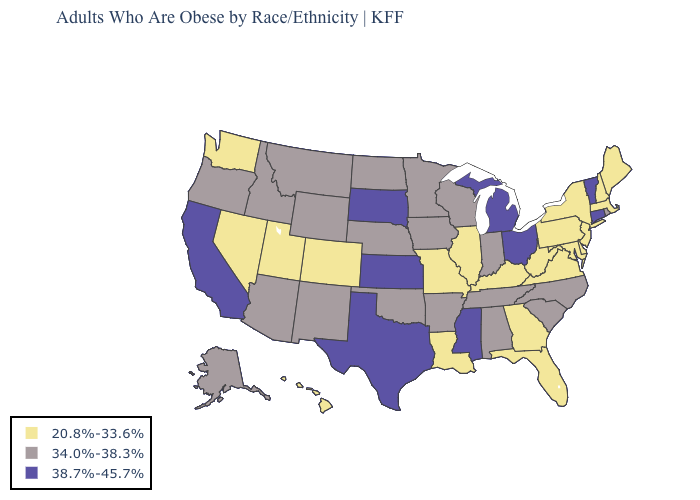Name the states that have a value in the range 34.0%-38.3%?
Be succinct. Alabama, Alaska, Arizona, Arkansas, Idaho, Indiana, Iowa, Minnesota, Montana, Nebraska, New Mexico, North Carolina, North Dakota, Oklahoma, Oregon, Rhode Island, South Carolina, Tennessee, Wisconsin, Wyoming. Name the states that have a value in the range 20.8%-33.6%?
Concise answer only. Colorado, Delaware, Florida, Georgia, Hawaii, Illinois, Kentucky, Louisiana, Maine, Maryland, Massachusetts, Missouri, Nevada, New Hampshire, New Jersey, New York, Pennsylvania, Utah, Virginia, Washington, West Virginia. Among the states that border New York , does Massachusetts have the highest value?
Short answer required. No. Does Virginia have a lower value than West Virginia?
Give a very brief answer. No. Does the first symbol in the legend represent the smallest category?
Give a very brief answer. Yes. Among the states that border North Dakota , does Montana have the lowest value?
Concise answer only. Yes. Does Mississippi have the highest value in the USA?
Quick response, please. Yes. Does Pennsylvania have a higher value than Virginia?
Keep it brief. No. Does the first symbol in the legend represent the smallest category?
Answer briefly. Yes. Does New Mexico have the highest value in the USA?
Be succinct. No. What is the value of New Mexico?
Concise answer only. 34.0%-38.3%. What is the highest value in states that border Minnesota?
Give a very brief answer. 38.7%-45.7%. Is the legend a continuous bar?
Concise answer only. No. Name the states that have a value in the range 38.7%-45.7%?
Be succinct. California, Connecticut, Kansas, Michigan, Mississippi, Ohio, South Dakota, Texas, Vermont. 